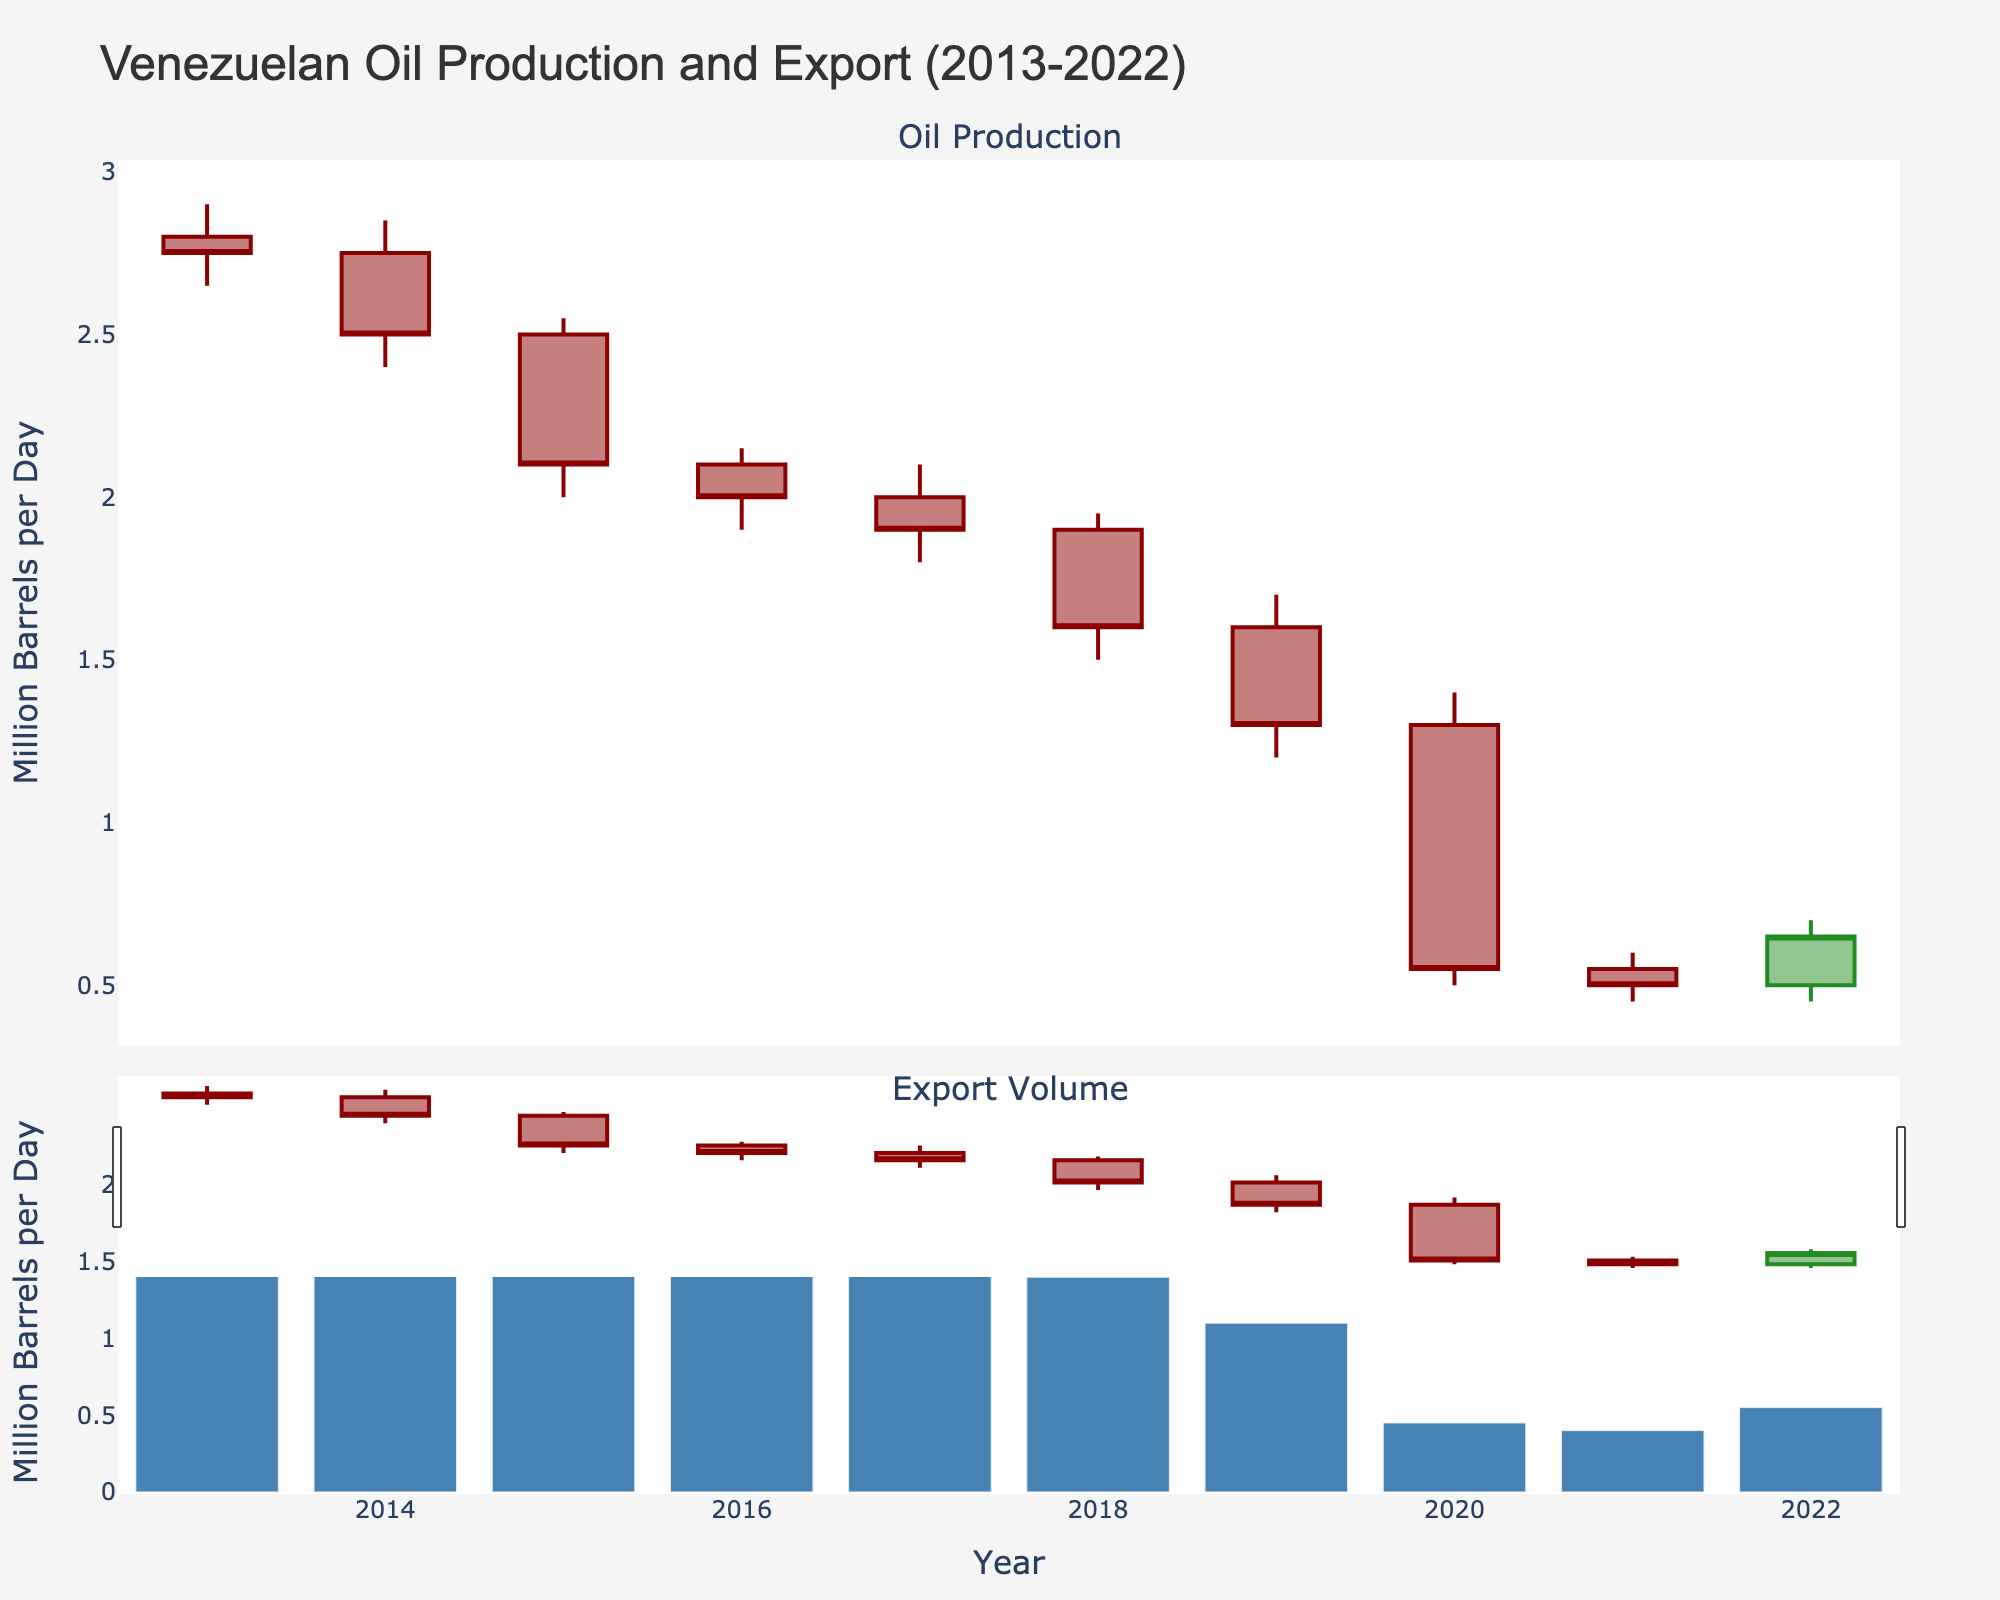What is the title of the figure? The title is typically placed at the top of the figure. In this case, it reads 'Venezuelan Oil Production and Export (2013-2022)'.
Answer: Venezuelan Oil Production and Export (2013-2022) How many years of data are presented in the figure? The x-axis represents the years from 2013 to 2022. Counting these, there are 10 years of data presented.
Answer: 10 What is the color of the bars representing export volumes? The bars for export volumes are colored blue, making them distinguishable from the candlestick chart above.
Answer: Blue What were the high and low values of oil production in 2015? In the Candlestick chart for 2015, the high value is 2.55 million barrels per day, and the low value is 2.00 million barrels per day.
Answer: 2.55 and 2.00 million barrels per day In which year does the highest identified export volume occur, and what is its value? The highest export volume is indicated by the tallest bar, which occurs in 2013, with a value of 2.35 million barrels per day.
Answer: 2013, 2.35 million barrels per day How does the closing oil production value in 2022 compare to the opening value in the same year? For 2022, the opening value is 0.50 million barrels per day, and the closing value is 0.65 million barrels per day. This shows an increase of 0.15 million barrels per day.
Answer: Closing value is higher by 0.15 million barrels per day What is the average export volume over the decade? Adding the export volumes for each year (2.35 + 2.15 + 1.90 + 1.80 + 1.70 + 1.40 + 1.10 + 0.45 + 0.40 + 0.55) gives 15.8 million barrels. Dividing by 10 years gives an average of 1.58 million barrels per day.
Answer: 1.58 million barrels per day Which year experienced the largest drop in high oil production value compared to the previous year? The largest drop occurs when comparing 2018 and 2019; the high value drops from 1.95 to 1.70, a difference of 0.25 million barrels per day.
Answer: 2019 Considering both charts, in which year did Venezuelan oil production see the highest variation between high and low values? The highest variation occurs in 2020, where the high was 1.40 million barrels per day and the low was 0.50 million barrels per day, a variation of 0.90 million barrels per day.
Answer: 2020 Which years had the same closing value of oil production? By inspecting the candlesticks, both 2016 and 2017 have a closing value of 2.00 million barrels per day.
Answer: 2016 and 2017 